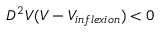<formula> <loc_0><loc_0><loc_500><loc_500>D ^ { 2 } V ( V - V _ { i n f l e x i o n } ) < 0</formula> 